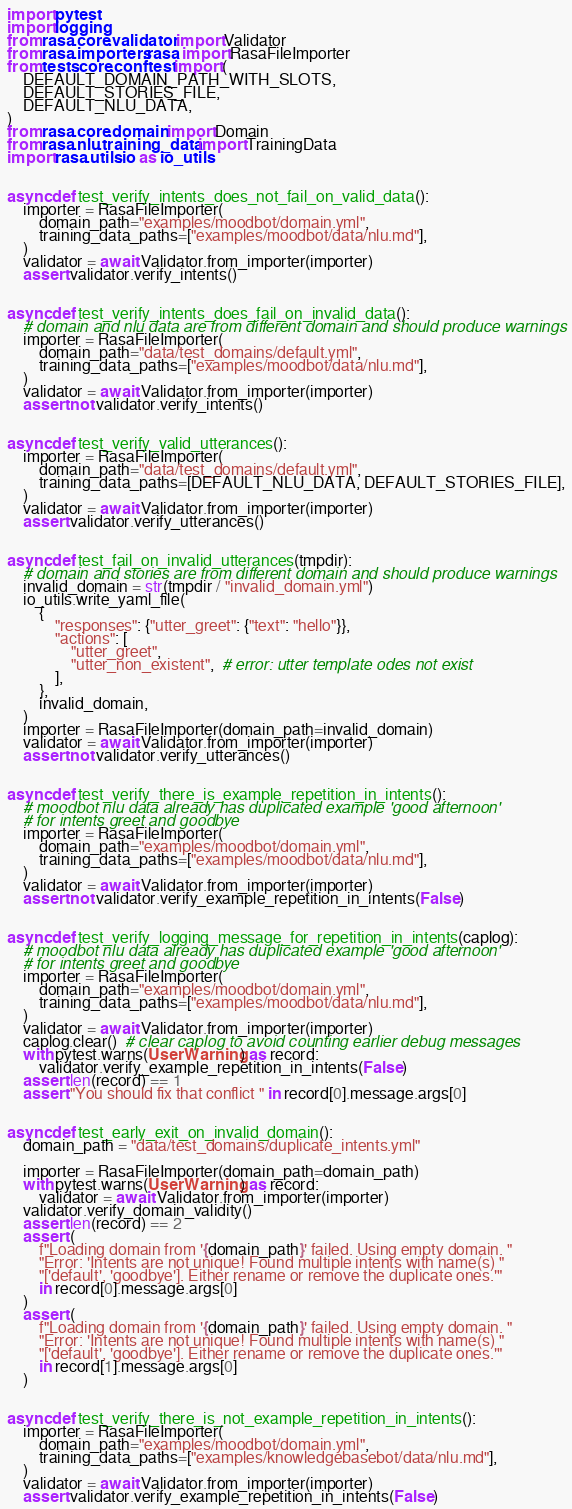<code> <loc_0><loc_0><loc_500><loc_500><_Python_>import pytest
import logging
from rasa.core.validator import Validator
from rasa.importers.rasa import RasaFileImporter
from tests.core.conftest import (
    DEFAULT_DOMAIN_PATH_WITH_SLOTS,
    DEFAULT_STORIES_FILE,
    DEFAULT_NLU_DATA,
)
from rasa.core.domain import Domain
from rasa.nlu.training_data import TrainingData
import rasa.utils.io as io_utils


async def test_verify_intents_does_not_fail_on_valid_data():
    importer = RasaFileImporter(
        domain_path="examples/moodbot/domain.yml",
        training_data_paths=["examples/moodbot/data/nlu.md"],
    )
    validator = await Validator.from_importer(importer)
    assert validator.verify_intents()


async def test_verify_intents_does_fail_on_invalid_data():
    # domain and nlu data are from different domain and should produce warnings
    importer = RasaFileImporter(
        domain_path="data/test_domains/default.yml",
        training_data_paths=["examples/moodbot/data/nlu.md"],
    )
    validator = await Validator.from_importer(importer)
    assert not validator.verify_intents()


async def test_verify_valid_utterances():
    importer = RasaFileImporter(
        domain_path="data/test_domains/default.yml",
        training_data_paths=[DEFAULT_NLU_DATA, DEFAULT_STORIES_FILE],
    )
    validator = await Validator.from_importer(importer)
    assert validator.verify_utterances()


async def test_fail_on_invalid_utterances(tmpdir):
    # domain and stories are from different domain and should produce warnings
    invalid_domain = str(tmpdir / "invalid_domain.yml")
    io_utils.write_yaml_file(
        {
            "responses": {"utter_greet": {"text": "hello"}},
            "actions": [
                "utter_greet",
                "utter_non_existent",  # error: utter template odes not exist
            ],
        },
        invalid_domain,
    )
    importer = RasaFileImporter(domain_path=invalid_domain)
    validator = await Validator.from_importer(importer)
    assert not validator.verify_utterances()


async def test_verify_there_is_example_repetition_in_intents():
    # moodbot nlu data already has duplicated example 'good afternoon'
    # for intents greet and goodbye
    importer = RasaFileImporter(
        domain_path="examples/moodbot/domain.yml",
        training_data_paths=["examples/moodbot/data/nlu.md"],
    )
    validator = await Validator.from_importer(importer)
    assert not validator.verify_example_repetition_in_intents(False)


async def test_verify_logging_message_for_repetition_in_intents(caplog):
    # moodbot nlu data already has duplicated example 'good afternoon'
    # for intents greet and goodbye
    importer = RasaFileImporter(
        domain_path="examples/moodbot/domain.yml",
        training_data_paths=["examples/moodbot/data/nlu.md"],
    )
    validator = await Validator.from_importer(importer)
    caplog.clear()  # clear caplog to avoid counting earlier debug messages
    with pytest.warns(UserWarning) as record:
        validator.verify_example_repetition_in_intents(False)
    assert len(record) == 1
    assert "You should fix that conflict " in record[0].message.args[0]


async def test_early_exit_on_invalid_domain():
    domain_path = "data/test_domains/duplicate_intents.yml"

    importer = RasaFileImporter(domain_path=domain_path)
    with pytest.warns(UserWarning) as record:
        validator = await Validator.from_importer(importer)
    validator.verify_domain_validity()
    assert len(record) == 2
    assert (
        f"Loading domain from '{domain_path}' failed. Using empty domain. "
        "Error: 'Intents are not unique! Found multiple intents with name(s) "
        "['default', 'goodbye']. Either rename or remove the duplicate ones.'"
        in record[0].message.args[0]
    )
    assert (
        f"Loading domain from '{domain_path}' failed. Using empty domain. "
        "Error: 'Intents are not unique! Found multiple intents with name(s) "
        "['default', 'goodbye']. Either rename or remove the duplicate ones.'"
        in record[1].message.args[0]
    )


async def test_verify_there_is_not_example_repetition_in_intents():
    importer = RasaFileImporter(
        domain_path="examples/moodbot/domain.yml",
        training_data_paths=["examples/knowledgebasebot/data/nlu.md"],
    )
    validator = await Validator.from_importer(importer)
    assert validator.verify_example_repetition_in_intents(False)
</code> 